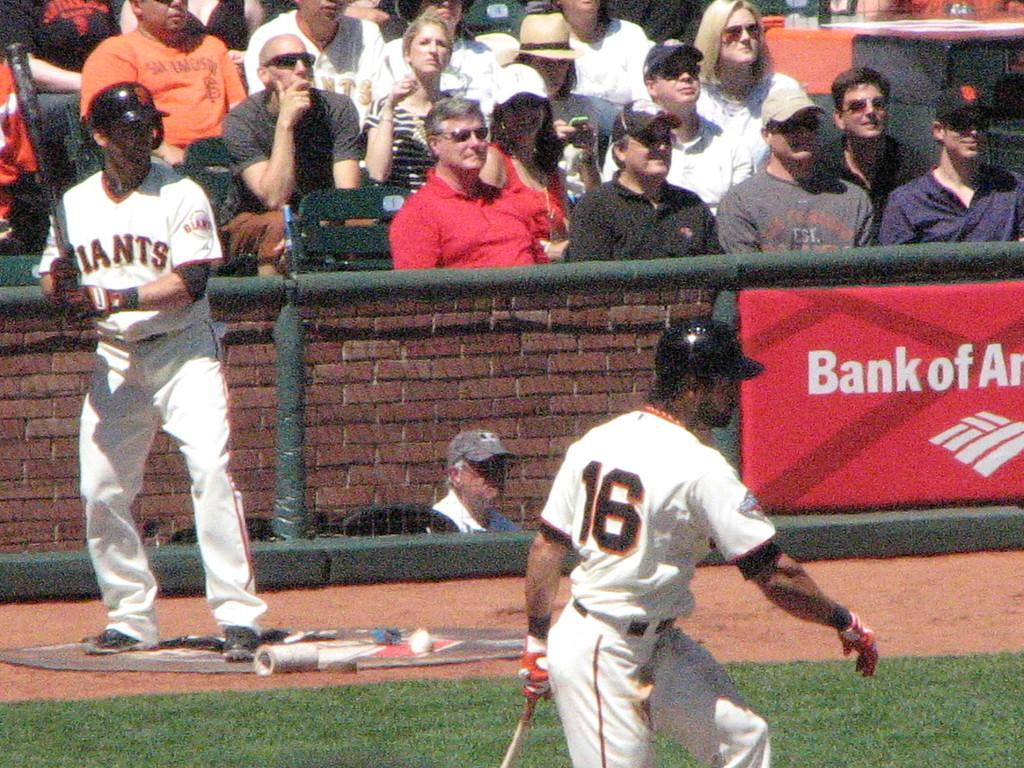<image>
Share a concise interpretation of the image provided. Two baseball players for the Giants are standing on the field, in front of a Bank of America banner. 